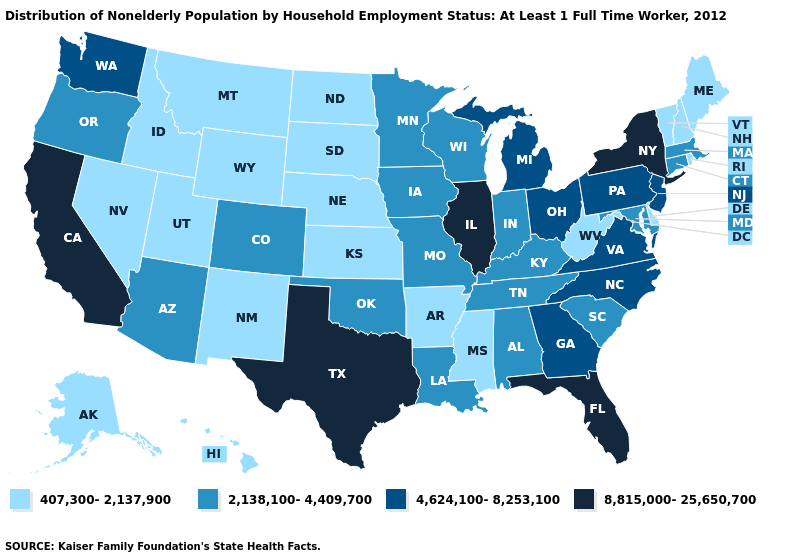What is the highest value in states that border Alabama?
Quick response, please. 8,815,000-25,650,700. What is the value of Alabama?
Keep it brief. 2,138,100-4,409,700. What is the highest value in the South ?
Concise answer only. 8,815,000-25,650,700. Does Mississippi have the lowest value in the USA?
Give a very brief answer. Yes. Does Arizona have a higher value than Connecticut?
Concise answer only. No. Name the states that have a value in the range 407,300-2,137,900?
Concise answer only. Alaska, Arkansas, Delaware, Hawaii, Idaho, Kansas, Maine, Mississippi, Montana, Nebraska, Nevada, New Hampshire, New Mexico, North Dakota, Rhode Island, South Dakota, Utah, Vermont, West Virginia, Wyoming. What is the value of Arkansas?
Answer briefly. 407,300-2,137,900. Does Maryland have a higher value than Mississippi?
Short answer required. Yes. Among the states that border Wyoming , does South Dakota have the lowest value?
Be succinct. Yes. What is the lowest value in states that border Kansas?
Keep it brief. 407,300-2,137,900. What is the highest value in states that border Kentucky?
Answer briefly. 8,815,000-25,650,700. Name the states that have a value in the range 8,815,000-25,650,700?
Keep it brief. California, Florida, Illinois, New York, Texas. Name the states that have a value in the range 4,624,100-8,253,100?
Be succinct. Georgia, Michigan, New Jersey, North Carolina, Ohio, Pennsylvania, Virginia, Washington. Name the states that have a value in the range 4,624,100-8,253,100?
Answer briefly. Georgia, Michigan, New Jersey, North Carolina, Ohio, Pennsylvania, Virginia, Washington. 